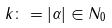Convert formula to latex. <formula><loc_0><loc_0><loc_500><loc_500>k \colon = | \alpha | \in N _ { 0 }</formula> 